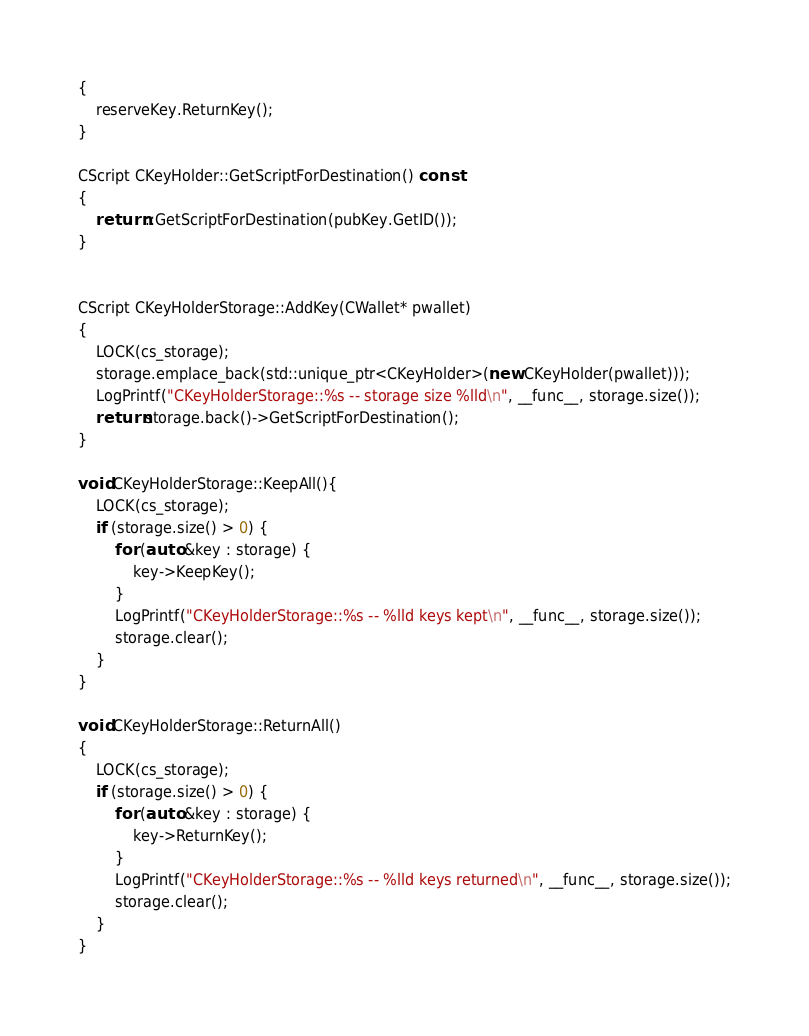Convert code to text. <code><loc_0><loc_0><loc_500><loc_500><_C++_>{
    reserveKey.ReturnKey();
}

CScript CKeyHolder::GetScriptForDestination() const
{
    return ::GetScriptForDestination(pubKey.GetID());
}


CScript CKeyHolderStorage::AddKey(CWallet* pwallet)
{
    LOCK(cs_storage);
    storage.emplace_back(std::unique_ptr<CKeyHolder>(new CKeyHolder(pwallet)));
    LogPrintf("CKeyHolderStorage::%s -- storage size %lld\n", __func__, storage.size());
    return storage.back()->GetScriptForDestination();
}

void CKeyHolderStorage::KeepAll(){
    LOCK(cs_storage);
    if (storage.size() > 0) {
        for (auto &key : storage) {
            key->KeepKey();
        }
        LogPrintf("CKeyHolderStorage::%s -- %lld keys kept\n", __func__, storage.size());
        storage.clear();
    }
}

void CKeyHolderStorage::ReturnAll()
{
    LOCK(cs_storage);
    if (storage.size() > 0) {
        for (auto &key : storage) {
            key->ReturnKey();
        }
        LogPrintf("CKeyHolderStorage::%s -- %lld keys returned\n", __func__, storage.size());
        storage.clear();
    }
}
</code> 